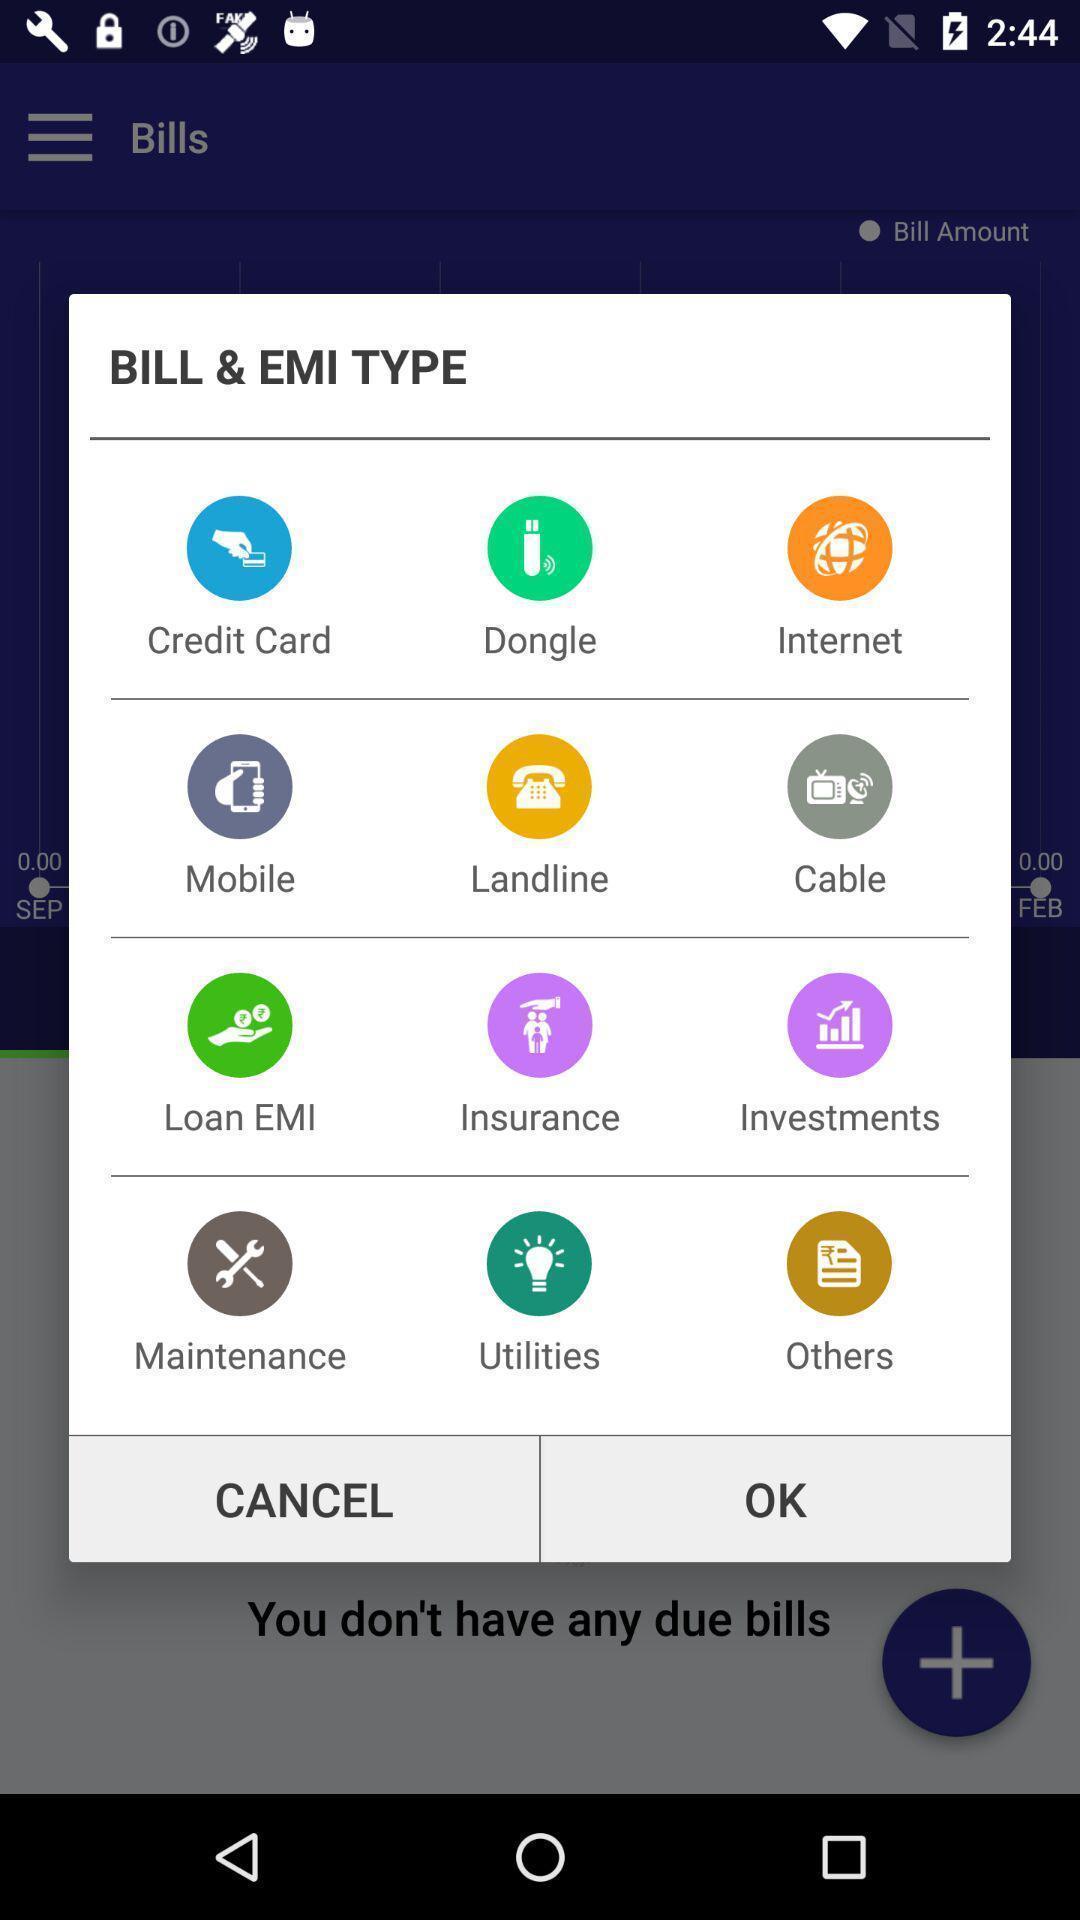Describe the visual elements of this screenshot. Pop-up showing different options to select emi type. 